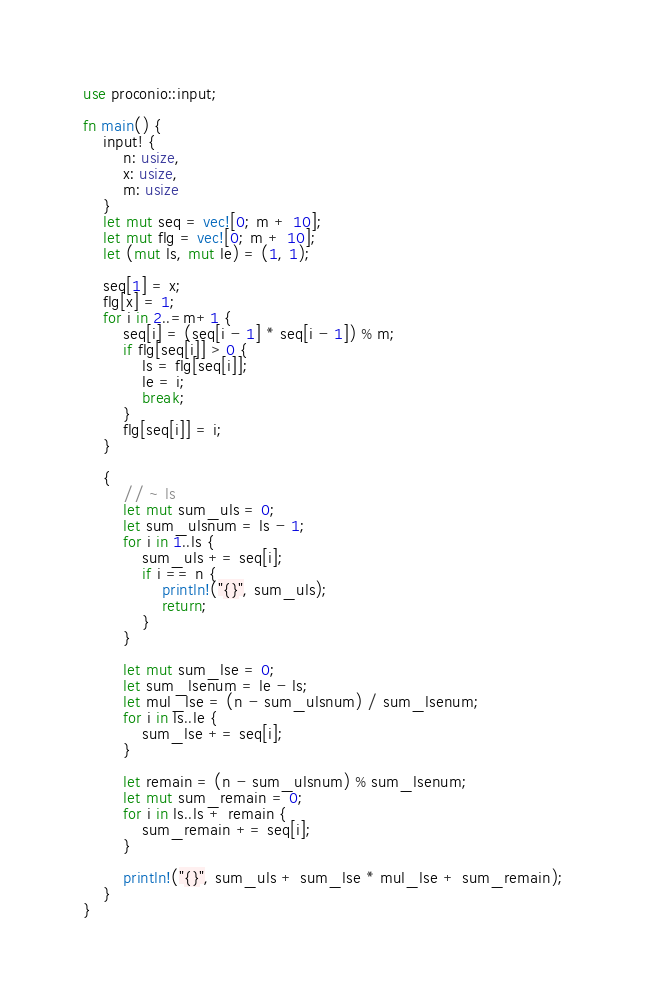<code> <loc_0><loc_0><loc_500><loc_500><_Rust_>use proconio::input;

fn main() {
    input! {
        n: usize,
        x: usize,
        m: usize
    }
    let mut seq = vec![0; m + 10];
    let mut flg = vec![0; m + 10];
    let (mut ls, mut le) = (1, 1);

    seq[1] = x;
    flg[x] = 1;
    for i in 2..=m+1 {
        seq[i] = (seq[i - 1] * seq[i - 1]) % m;
        if flg[seq[i]] > 0 {
            ls = flg[seq[i]];
            le = i;
            break;
        }
        flg[seq[i]] = i;
    }

    {
        // ~ ls
        let mut sum_uls = 0;
        let sum_ulsnum = ls - 1;
        for i in 1..ls {
            sum_uls += seq[i];
            if i == n {
                println!("{}", sum_uls);
                return;
            }
        }

        let mut sum_lse = 0;
        let sum_lsenum = le - ls;
        let mul_lse = (n - sum_ulsnum) / sum_lsenum;
        for i in ls..le {
            sum_lse += seq[i];
        }

        let remain = (n - sum_ulsnum) % sum_lsenum;
        let mut sum_remain = 0;
        for i in ls..ls + remain {
            sum_remain += seq[i];
        }

        println!("{}", sum_uls + sum_lse * mul_lse + sum_remain);
    }
}
</code> 